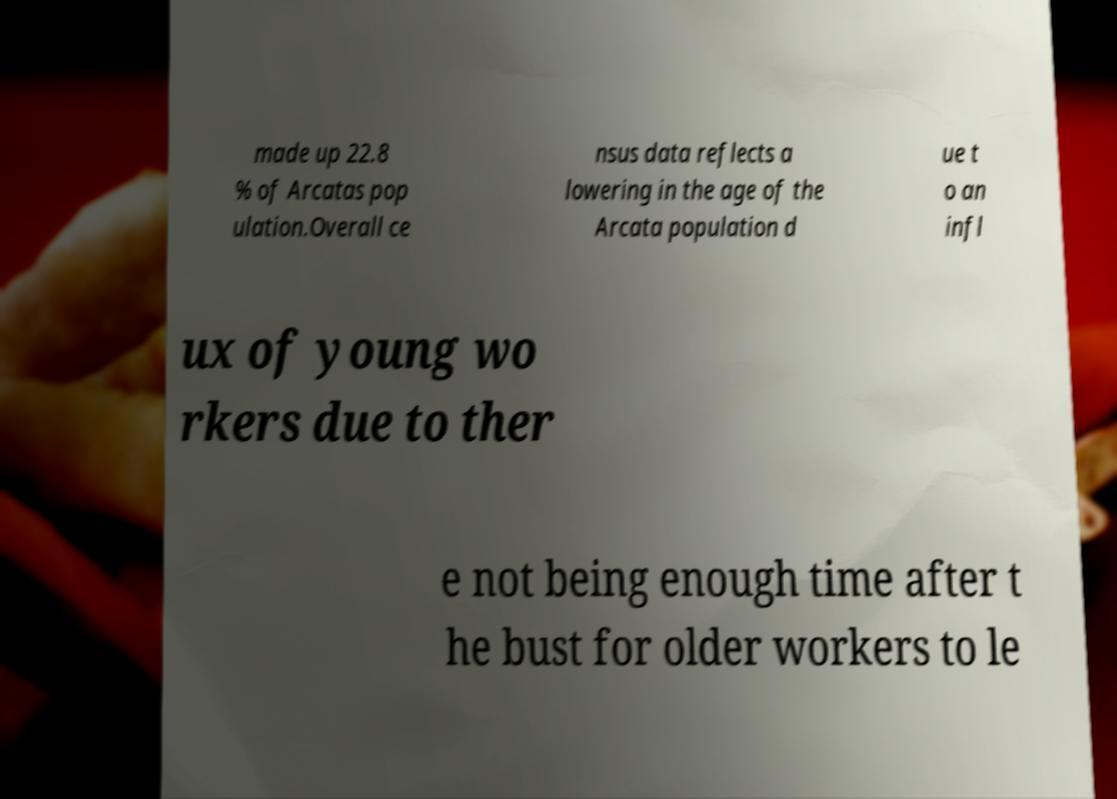Could you assist in decoding the text presented in this image and type it out clearly? made up 22.8 % of Arcatas pop ulation.Overall ce nsus data reflects a lowering in the age of the Arcata population d ue t o an infl ux of young wo rkers due to ther e not being enough time after t he bust for older workers to le 